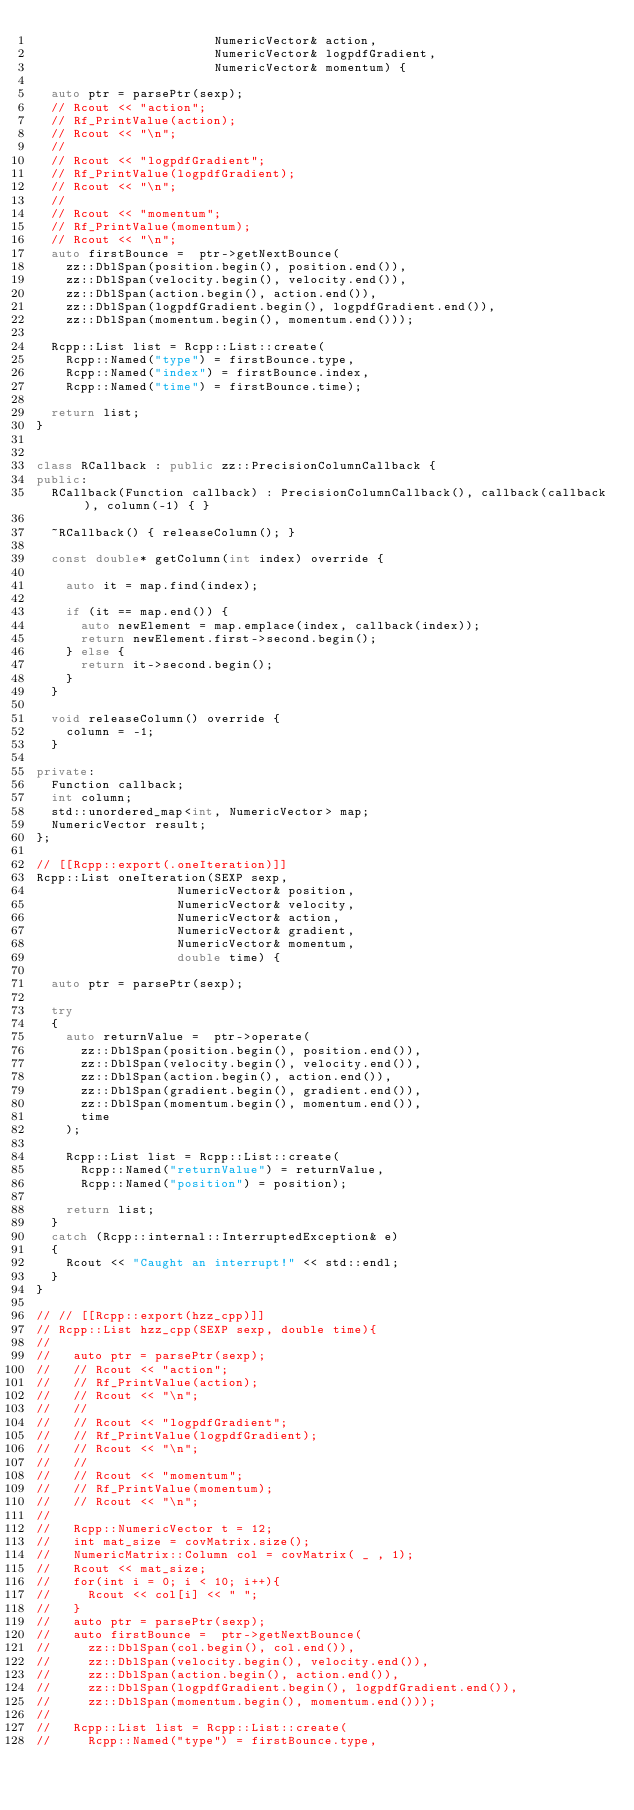Convert code to text. <code><loc_0><loc_0><loc_500><loc_500><_C++_>                        NumericVector& action,
                        NumericVector& logpdfGradient,
                        NumericVector& momentum) {
  
  auto ptr = parsePtr(sexp);
  // Rcout << "action";
  // Rf_PrintValue(action);
  // Rcout << "\n";
  // 
  // Rcout << "logpdfGradient";
  // Rf_PrintValue(logpdfGradient);
  // Rcout << "\n";
  // 
  // Rcout << "momentum";
  // Rf_PrintValue(momentum);
  // Rcout << "\n";
  auto firstBounce =  ptr->getNextBounce(
    zz::DblSpan(position.begin(), position.end()),
    zz::DblSpan(velocity.begin(), velocity.end()),
    zz::DblSpan(action.begin(), action.end()),
    zz::DblSpan(logpdfGradient.begin(), logpdfGradient.end()),
    zz::DblSpan(momentum.begin(), momentum.end()));
  
  Rcpp::List list = Rcpp::List::create(
    Rcpp::Named("type") = firstBounce.type,
    Rcpp::Named("index") = firstBounce.index,
    Rcpp::Named("time") = firstBounce.time);
  
  return list;  
}


class RCallback : public zz::PrecisionColumnCallback {
public:
  RCallback(Function callback) : PrecisionColumnCallback(), callback(callback), column(-1) { }
  
  ~RCallback() { releaseColumn(); }
  
  const double* getColumn(int index) override {
    
    auto it = map.find(index);
    
    if (it == map.end()) {
      auto newElement = map.emplace(index, callback(index));
      return newElement.first->second.begin();
    } else {
      return it->second.begin();
    }
  }
  
  void releaseColumn() override {
    column = -1;
  }
  
private:
  Function callback;
  int column;
  std::unordered_map<int, NumericVector> map;
  NumericVector result;
};

// [[Rcpp::export(.oneIteration)]]
Rcpp::List oneIteration(SEXP sexp,
                   NumericVector& position,
                   NumericVector& velocity,
                   NumericVector& action,
                   NumericVector& gradient,
                   NumericVector& momentum,
                   double time) {

  auto ptr = parsePtr(sexp);
  
  try
  {
    auto returnValue =  ptr->operate(
      zz::DblSpan(position.begin(), position.end()),
      zz::DblSpan(velocity.begin(), velocity.end()),
      zz::DblSpan(action.begin(), action.end()),
      zz::DblSpan(gradient.begin(), gradient.end()),
      zz::DblSpan(momentum.begin(), momentum.end()),
      time
    );
    
    Rcpp::List list = Rcpp::List::create(
      Rcpp::Named("returnValue") = returnValue,
      Rcpp::Named("position") = position);
    
    return list;
  }
  catch (Rcpp::internal::InterruptedException& e)
  {
    Rcout << "Caught an interrupt!" << std::endl;
  }
}

// // [[Rcpp::export(hzz_cpp)]]
// Rcpp::List hzz_cpp(SEXP sexp, double time){
//   
//   auto ptr = parsePtr(sexp);
//   // Rcout << "action";
//   // Rf_PrintValue(action);
//   // Rcout << "\n";
//   // 
//   // Rcout << "logpdfGradient";
//   // Rf_PrintValue(logpdfGradient);
//   // Rcout << "\n";
//   // 
//   // Rcout << "momentum";
//   // Rf_PrintValue(momentum);
//   // Rcout << "\n";
// 
//   Rcpp::NumericVector t = 12;
//   int mat_size = covMatrix.size();
//   NumericMatrix::Column col = covMatrix( _ , 1);  
//   Rcout << mat_size;
//   for(int i = 0; i < 10; i++){
//     Rcout << col[i] << " ";
//   }
//   auto ptr = parsePtr(sexp);
//   auto firstBounce =  ptr->getNextBounce(
//     zz::DblSpan(col.begin(), col.end()),
//     zz::DblSpan(velocity.begin(), velocity.end()),
//     zz::DblSpan(action.begin(), action.end()),
//     zz::DblSpan(logpdfGradient.begin(), logpdfGradient.end()),
//     zz::DblSpan(momentum.begin(), momentum.end()));
//   
//   Rcpp::List list = Rcpp::List::create(
//     Rcpp::Named("type") = firstBounce.type,</code> 